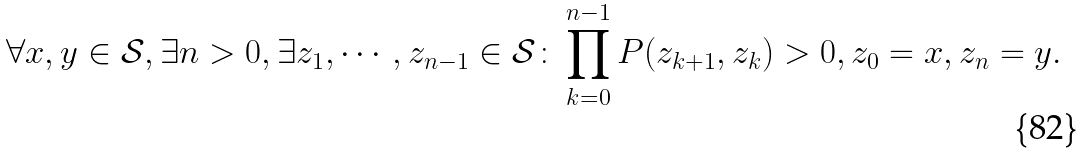Convert formula to latex. <formula><loc_0><loc_0><loc_500><loc_500>\forall x , y \in \mathcal { S } , \exists n > 0 , \exists z _ { 1 } , \cdots , z _ { n - 1 } \in { \mathcal { S } } \colon \prod _ { k = 0 } ^ { n - 1 } P ( z _ { k + 1 } , z _ { k } ) > 0 , z _ { 0 } = x , z _ { n } = y .</formula> 